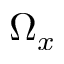<formula> <loc_0><loc_0><loc_500><loc_500>\Omega _ { x }</formula> 